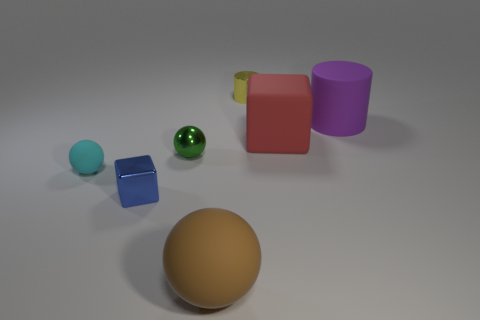What material is the yellow thing that is the same size as the green sphere?
Give a very brief answer. Metal. There is a tiny cyan thing that is the same shape as the green object; what material is it?
Make the answer very short. Rubber. How many other things are the same size as the brown thing?
Keep it short and to the point. 2. What shape is the blue object?
Keep it short and to the point. Cube. What is the color of the shiny thing that is both in front of the red thing and behind the cyan object?
Give a very brief answer. Green. What is the brown sphere made of?
Your answer should be compact. Rubber. There is a red object on the right side of the small green object; what shape is it?
Your answer should be compact. Cube. The other ball that is the same size as the green metal ball is what color?
Give a very brief answer. Cyan. Does the big thing that is on the left side of the red block have the same material as the large red thing?
Give a very brief answer. Yes. There is a metal thing that is in front of the big matte cube and on the right side of the tiny metal cube; how big is it?
Your answer should be very brief. Small. 